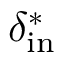Convert formula to latex. <formula><loc_0><loc_0><loc_500><loc_500>\delta _ { i n } ^ { * }</formula> 